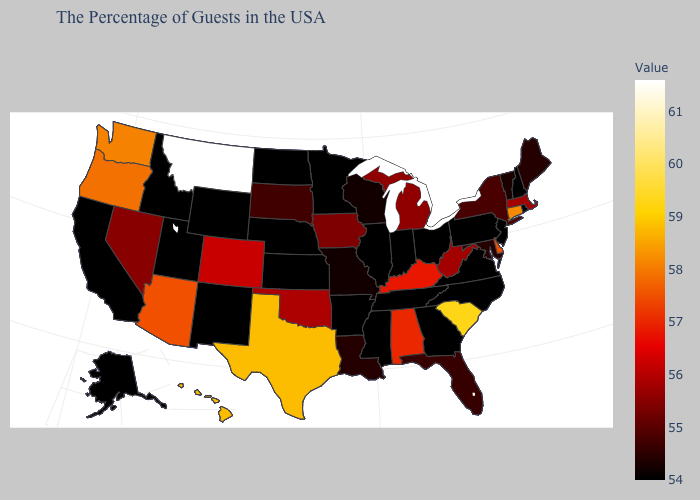Does the map have missing data?
Be succinct. No. Among the states that border New Jersey , does Delaware have the lowest value?
Be succinct. No. Among the states that border Missouri , does Kansas have the highest value?
Short answer required. No. Does Michigan have the highest value in the MidWest?
Concise answer only. Yes. Which states have the highest value in the USA?
Short answer required. Montana. 